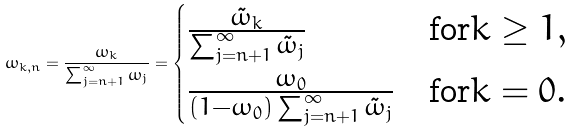Convert formula to latex. <formula><loc_0><loc_0><loc_500><loc_500>\omega _ { k , n } = \frac { \omega _ { k } } { \sum _ { j = n + 1 } ^ { \infty } \omega _ { j } } = \begin{cases} \frac { \tilde { \omega } _ { k } } { \sum _ { j = n + 1 } ^ { \infty } \tilde { \omega } _ { j } } & \text {for} k \geq 1 , \\ \frac { \omega _ { 0 } } { ( 1 - \omega _ { 0 } ) \sum _ { j = n + 1 } ^ { \infty } \tilde { \omega } _ { j } } & \text {for} k = 0 . \end{cases}</formula> 